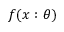Convert formula to latex. <formula><loc_0><loc_0><loc_500><loc_500>f ( x \colon \theta )</formula> 